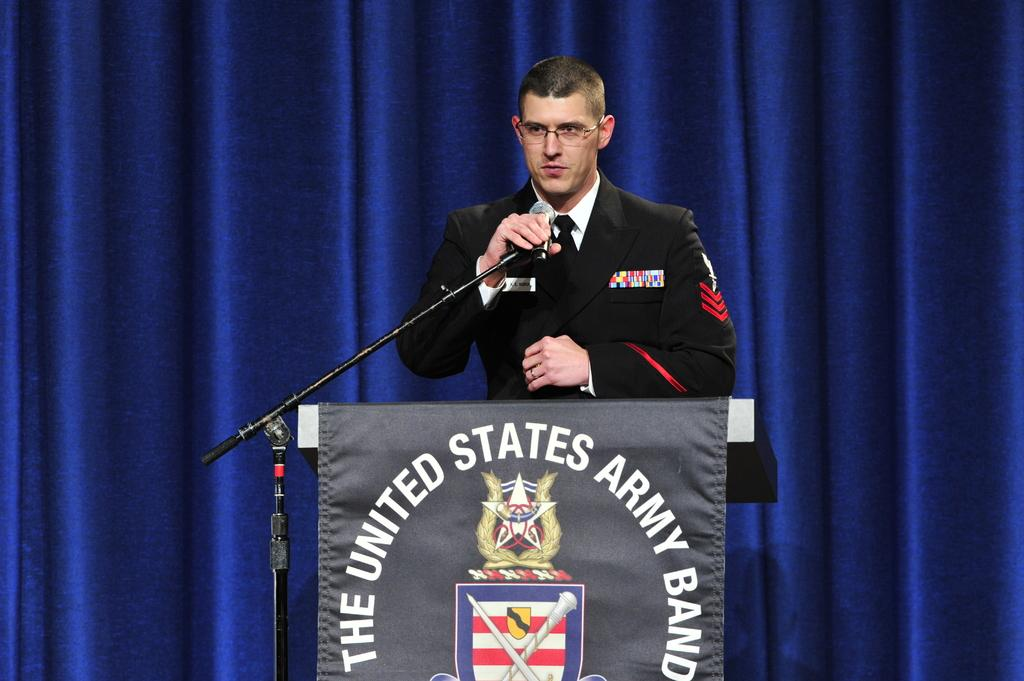<image>
Summarize the visual content of the image. a man talking at a podium for The United States Army Band 